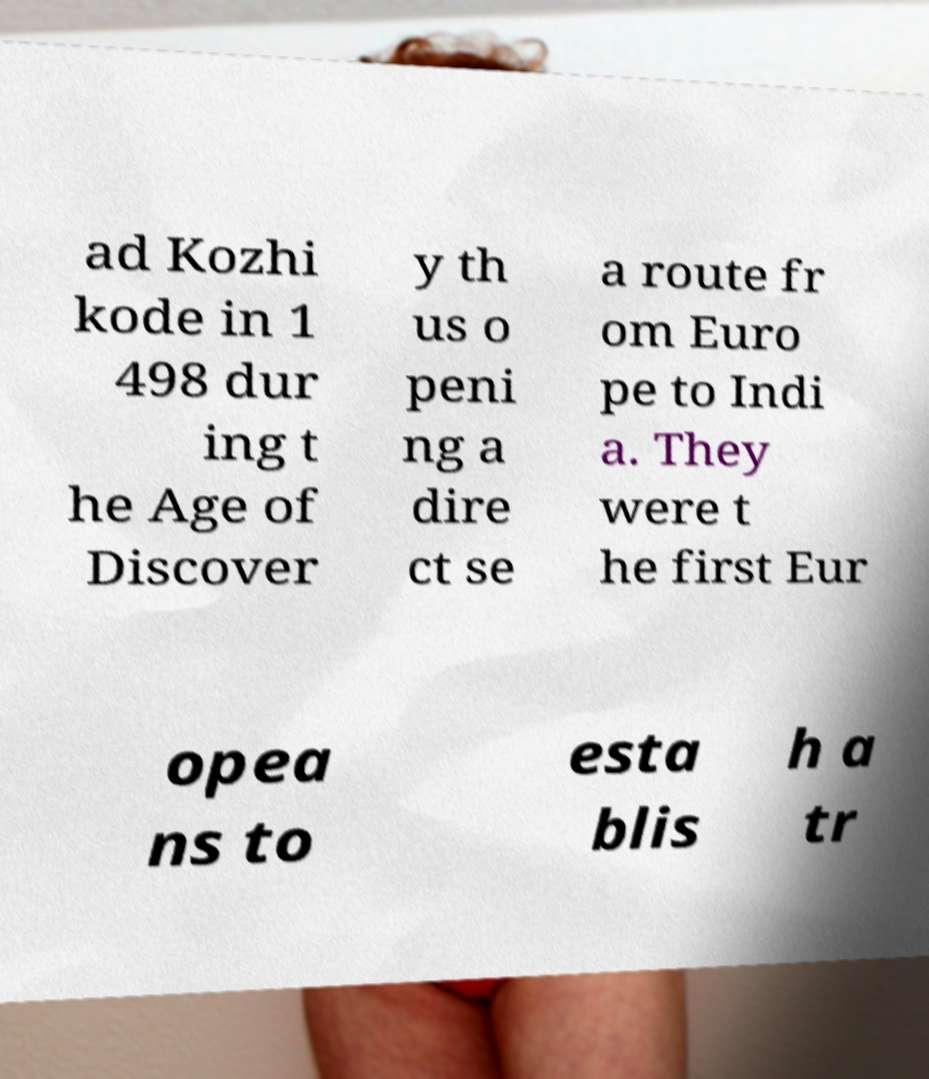Can you accurately transcribe the text from the provided image for me? ad Kozhi kode in 1 498 dur ing t he Age of Discover y th us o peni ng a dire ct se a route fr om Euro pe to Indi a. They were t he first Eur opea ns to esta blis h a tr 